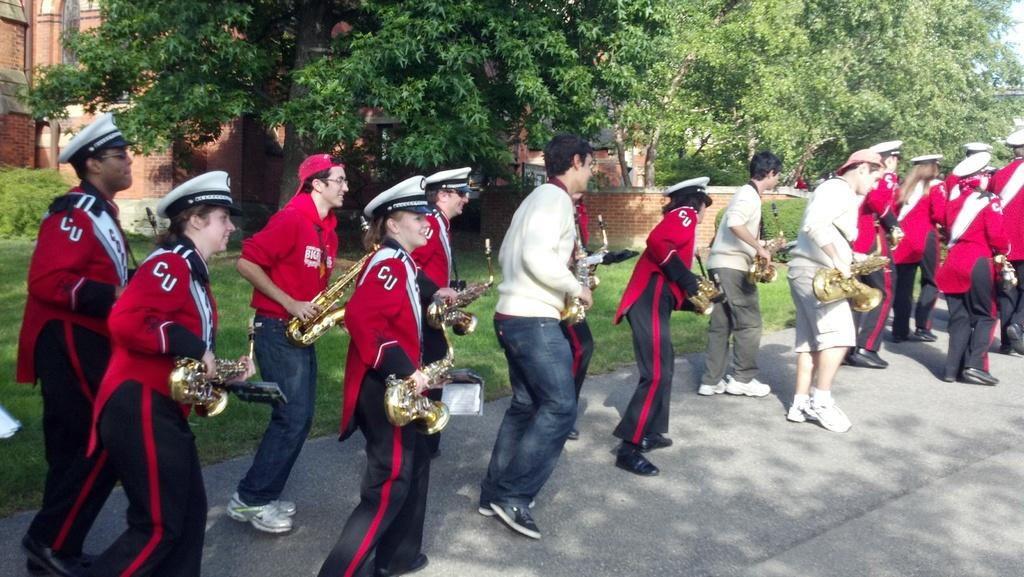What are the people in the middle of the image doing? The people are standing in the middle of the image and holding musical instruments. What type of vegetation can be seen in the image? Plants, grass, and trees are visible in the image. What is in the background of the image? There are buildings in the background of the image. What type of meat is being grilled in the image? There is no meat or grill present in the image. What country is the image taken in? The image does not provide any information about the country in which it was taken. 